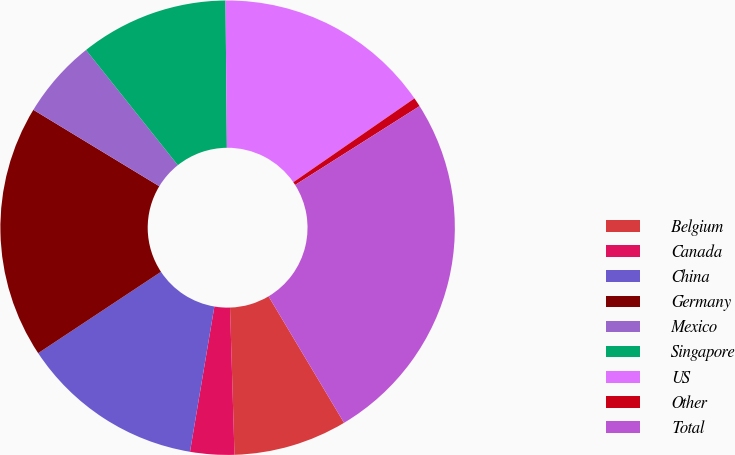Convert chart to OTSL. <chart><loc_0><loc_0><loc_500><loc_500><pie_chart><fcel>Belgium<fcel>Canada<fcel>China<fcel>Germany<fcel>Mexico<fcel>Singapore<fcel>US<fcel>Other<fcel>Total<nl><fcel>8.08%<fcel>3.13%<fcel>13.04%<fcel>17.99%<fcel>5.61%<fcel>10.56%<fcel>15.51%<fcel>0.65%<fcel>25.42%<nl></chart> 